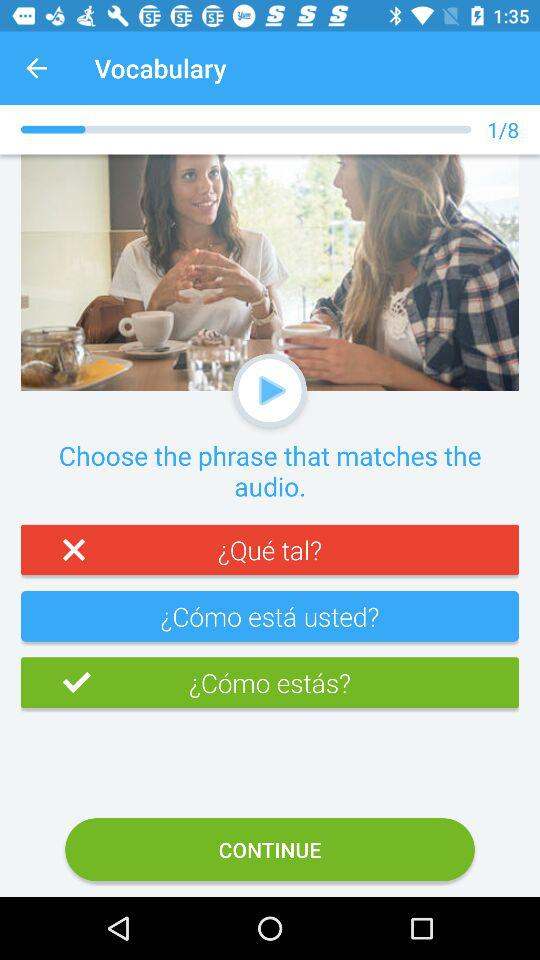How many questions in total are there in "Vocabulary"? There are 8 questions. 